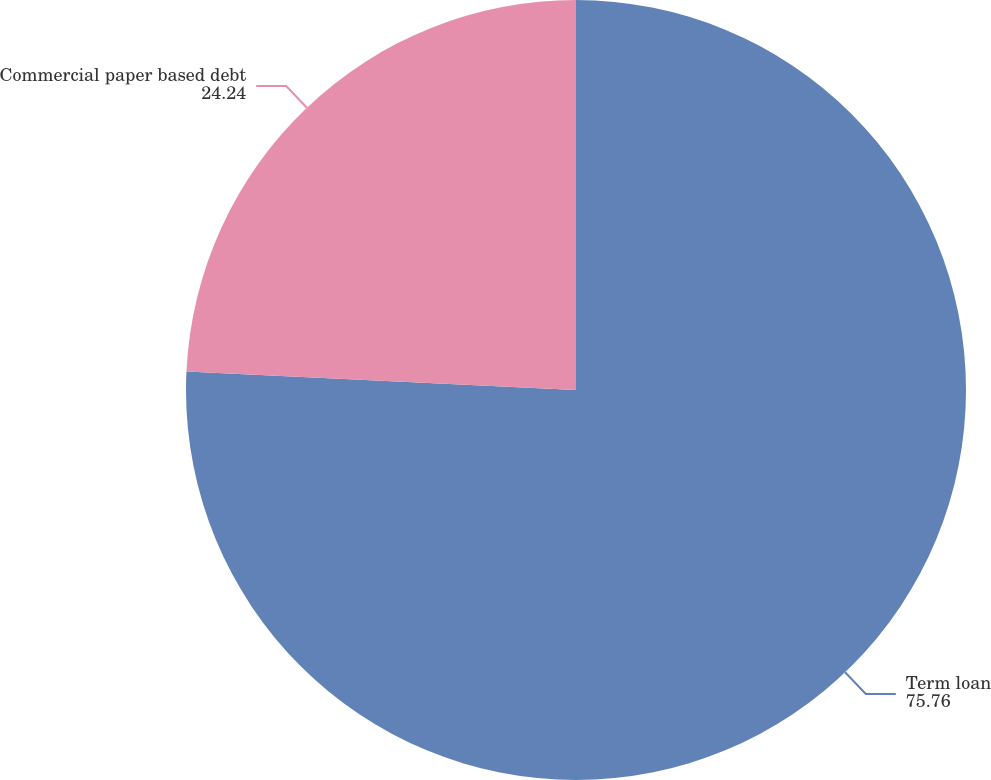<chart> <loc_0><loc_0><loc_500><loc_500><pie_chart><fcel>Term loan<fcel>Commercial paper based debt<nl><fcel>75.76%<fcel>24.24%<nl></chart> 